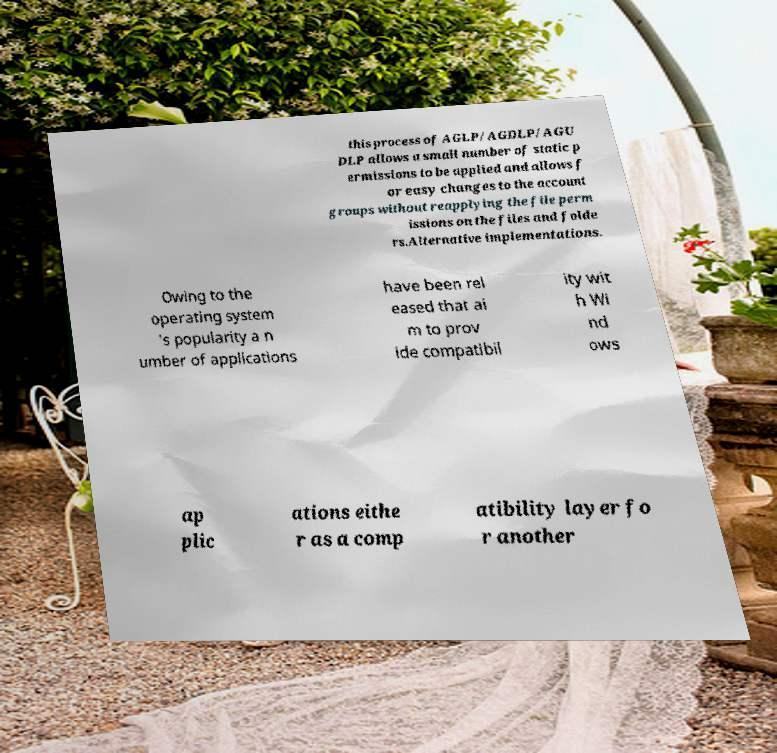Could you assist in decoding the text presented in this image and type it out clearly? this process of AGLP/AGDLP/AGU DLP allows a small number of static p ermissions to be applied and allows f or easy changes to the account groups without reapplying the file perm issions on the files and folde rs.Alternative implementations. Owing to the operating system 's popularity a n umber of applications have been rel eased that ai m to prov ide compatibil ity wit h Wi nd ows ap plic ations eithe r as a comp atibility layer fo r another 